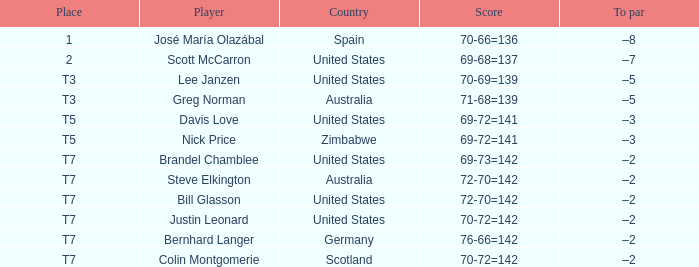Can you name the u.s. player who has achieved a to par of -5? Lee Janzen. 